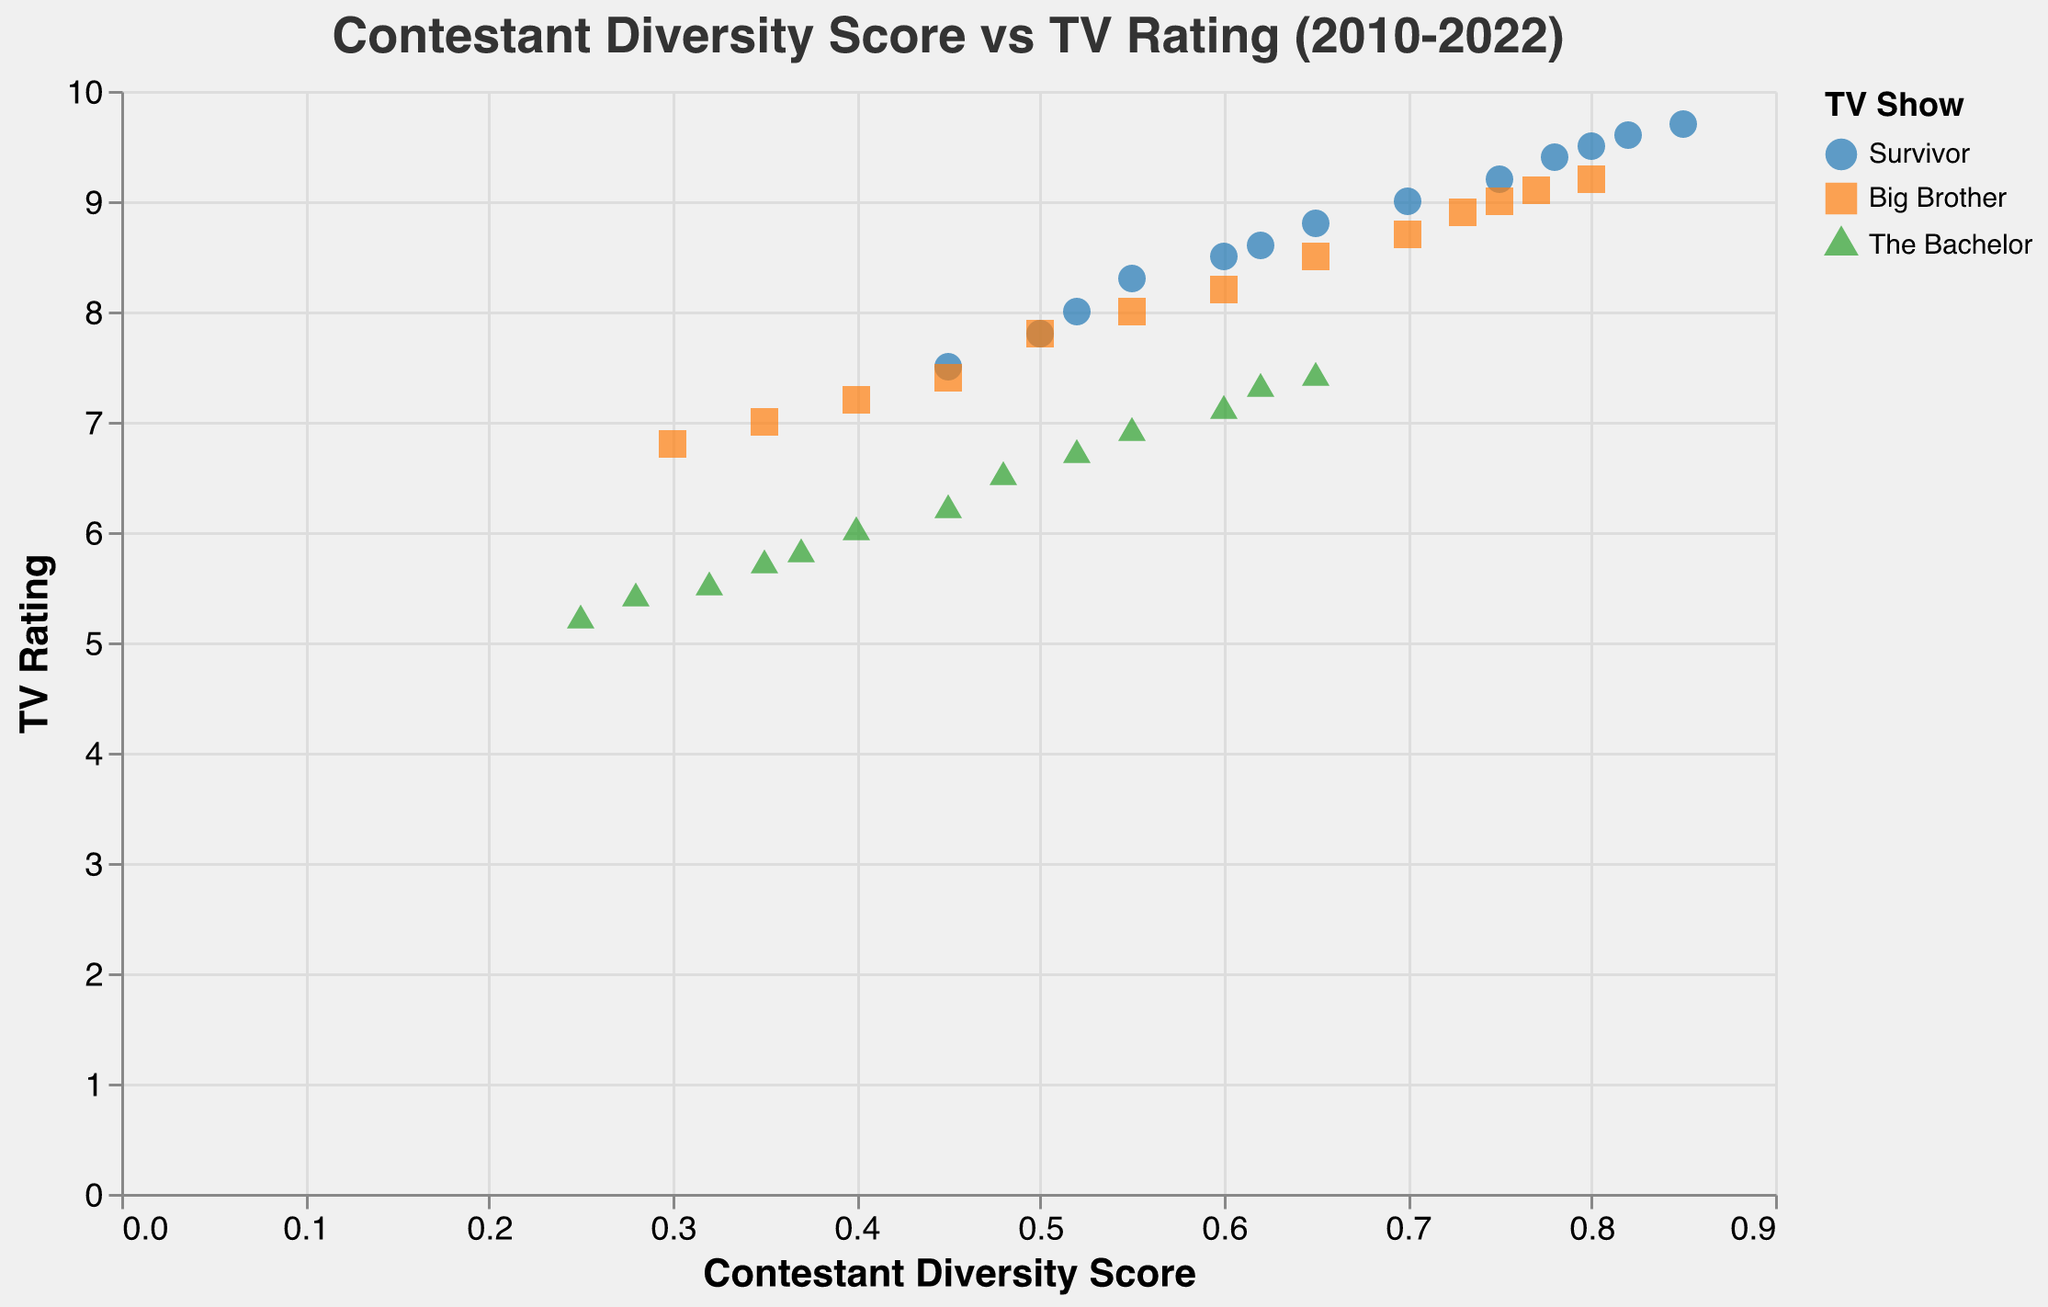What's the title of the figure? The title is at the top of the figure and reads "Contestant Diversity Score vs TV Rating (2010-2022)"
Answer: Contestant Diversity Score vs TV Rating (2010-2022) What are the axes labels? The x-axis is labeled "Contestant Diversity Score" and the y-axis is labeled "TV Rating"
Answer: Contestant Diversity Score, TV Rating How many data points are there for "Survivor"? Count the number of unique points that have the "Survivor" label in the legend
Answer: 13 Which TV show has the highest diversity score in 2022? Find the data points for 2022 and check which show has the highest value on the x-axis
Answer: Survivor What is the overall trend depicted by the trend line? The trend line indicates the general direction of the data points. If the line slopes upwards, it indicates a positive relationship.
Answer: Positive relationship Compare the highest TV ratings achieved by "Survivor" and "The Bachelor" Identify the maximum TV Rating for each show and compare them
Answer: Survivor has a higher maximum TV rating What is the average Contestant Diversity Score for "Big Brother" between 2010 and 2022? Sum all Contestant Diversity Scores for "Big Brother" and divide by the number of data points (13 in this case)
Answer: 0.59 Between 2010 and 2022, which year shows the most improvement in diversity score for "The Bachelor"? Compare the diversity scores for "The Bachelor" across all years; the year with the greatest increase from the previous year indicates the most improvement
Answer: 2016 Which show has the most consistent TV ratings over the years? Observe the spread of data points for each show in the y-axis; the show with the least spread has the most consistent ratings.
Answer: Survivor Do any data points fall significantly below the trend line? Check for any points that are considerably below the trend line, indicating much lower TV Ratings than expected for their diversity score.
Answer: Yes, points for "The Bachelor" 